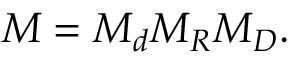<formula> <loc_0><loc_0><loc_500><loc_500>M = M _ { d } M _ { R } M _ { D } .</formula> 